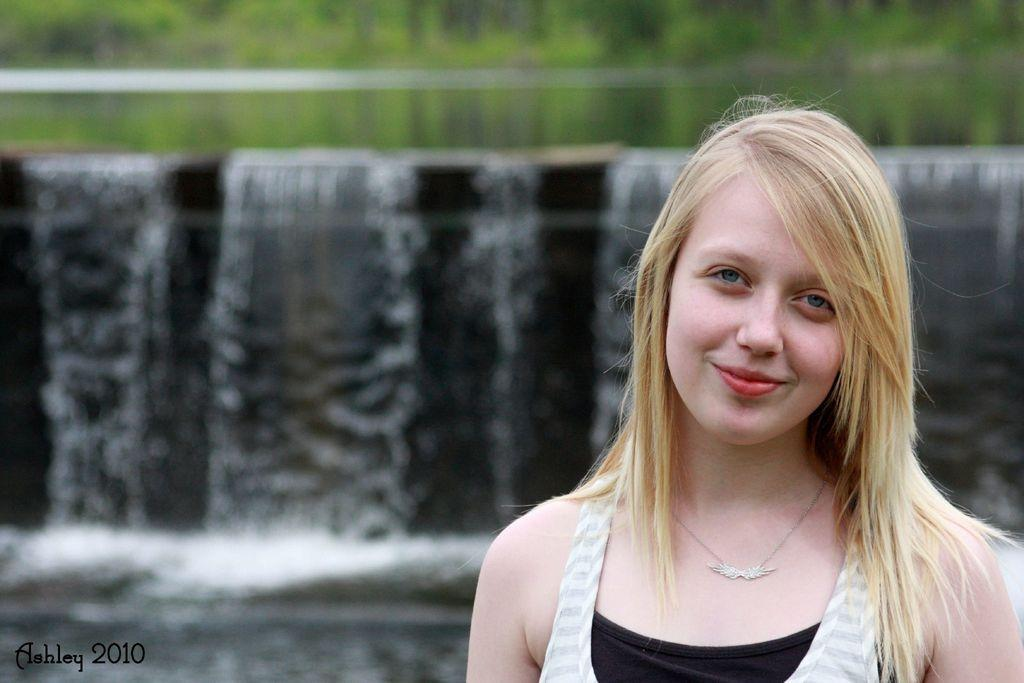Who is present on the right side of the image? There is a woman on the right side of the image. What can be seen in the background of the image? There is a water fountain in the background of the image. What type of plants can be seen on the woman's journey in the image? There is no journey or plants present in the image; it only features a woman and a water fountain in the background. 